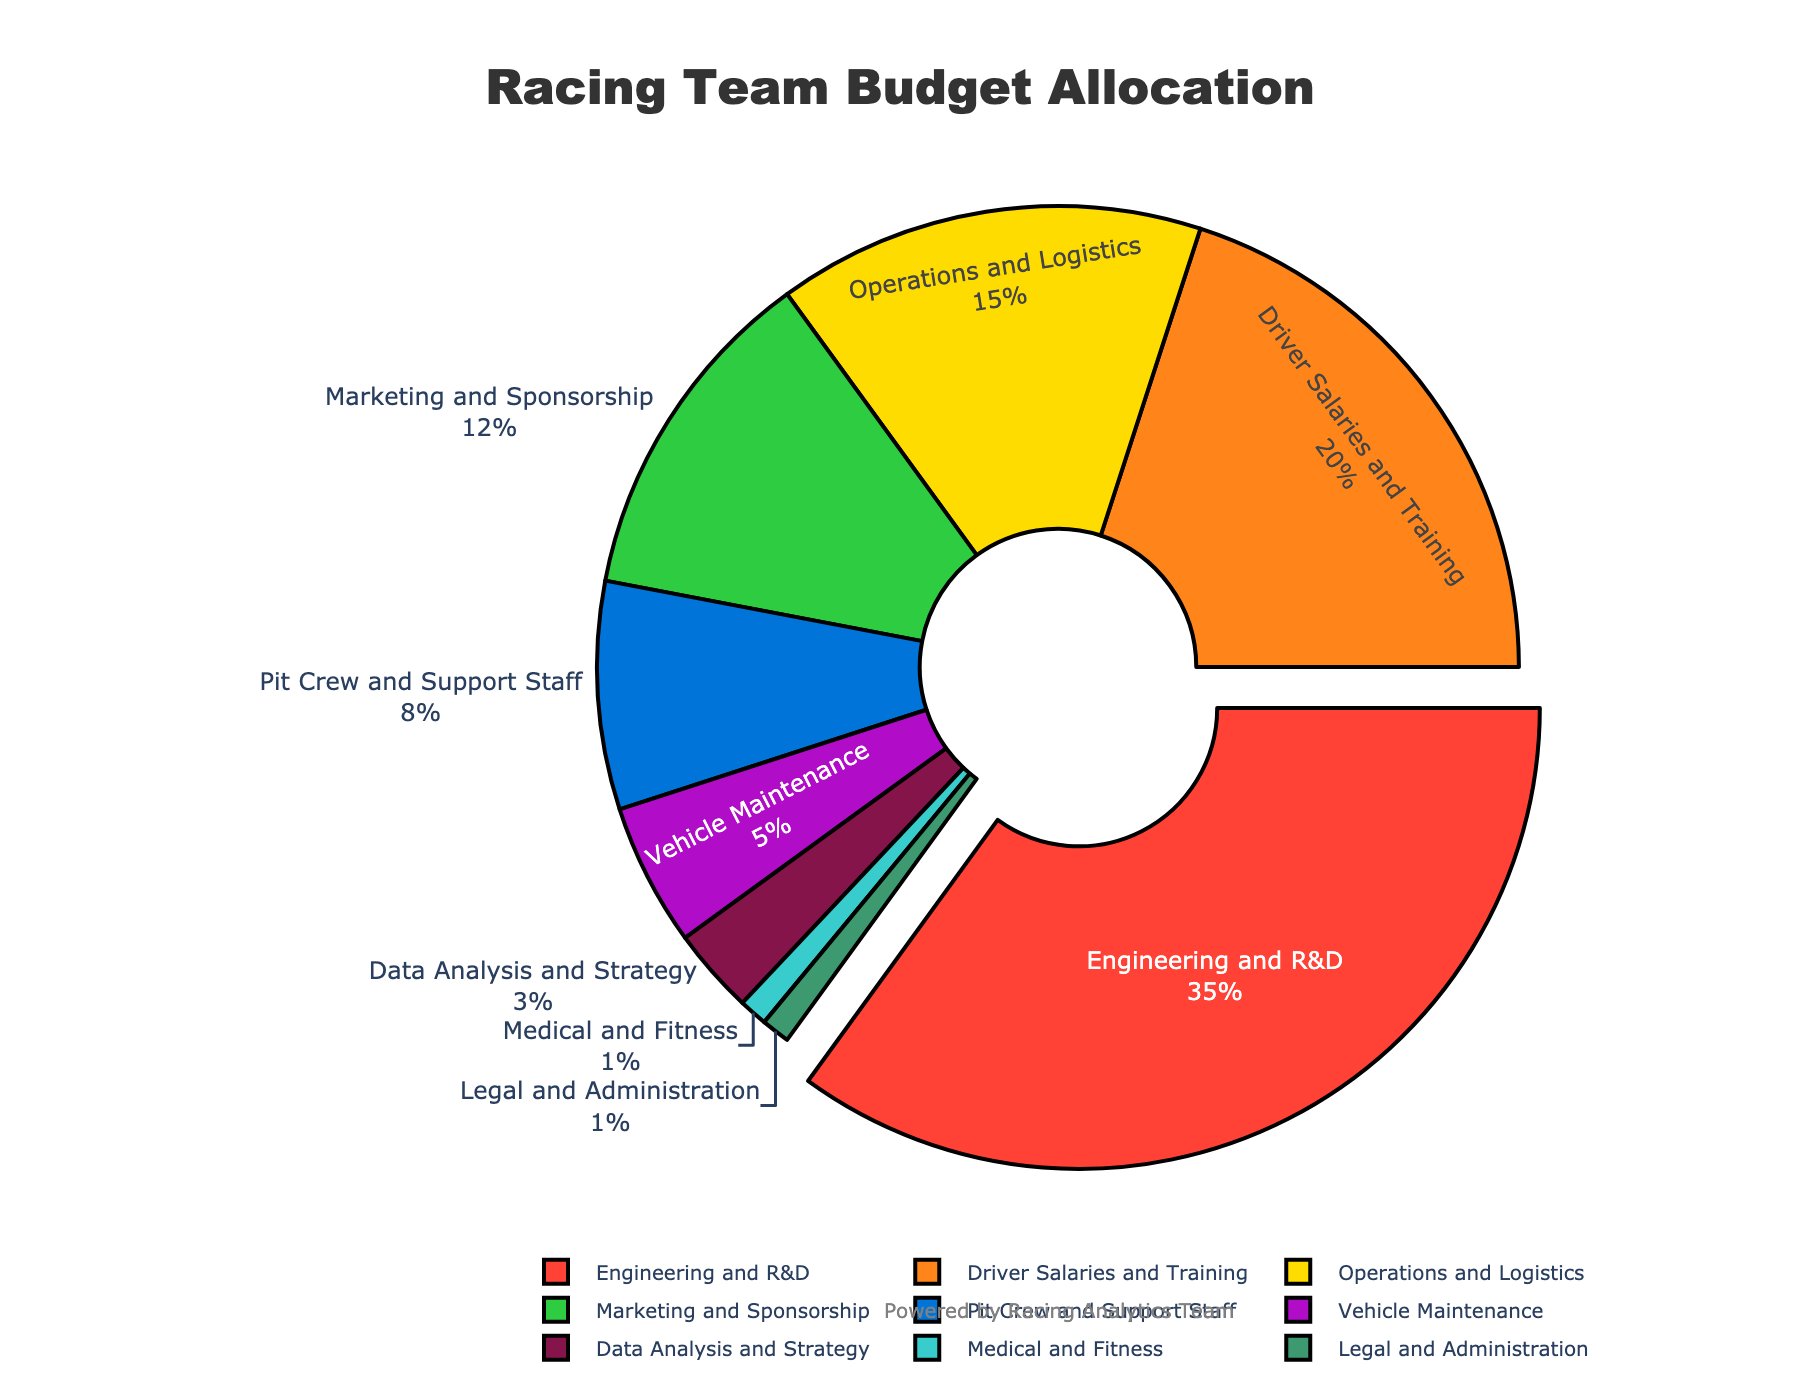What percentage of the budget is allocated to Engineering and R&D? The "Engineering and R&D" segment can be easily identified, and its percentage is marked next to it.
Answer: 35% Which two departments receive the smallest portions of the budget? By looking at the smallest segments of the pie chart and checking their labels, we see "Medical and Fitness" and "Legal and Administration"
Answer: Medical and Fitness and Legal and Administration How much more budget is allocated to Engineering and R&D compared to Marketing and Sponsorship? First, find the percentage for each department: Engineering and R&D (35%) and Marketing and Sponsorship (12%). Then subtract the two values: 35% - 12% = 23%
Answer: 23% Which department has the third highest budget allocation? By ordering the segments in descending order of their percentages, the top three are "Engineering and R&D", "Driver Salaries and Training", and "Operations and Logistics".
Answer: Operations and Logistics What is the combined budget allocation for Driver Salaries and Training and Operations and Logistics? Adding the percentages of "Driver Salaries and Training" (20%) and "Operations and Logistics" (15%) gives 20% + 15% = 35%
Answer: 35% How much more budget percentage does the Engineering and R&D department have compared to the Pit Crew and Support Staff? Subtract the budget percentage of the Pit Crew and Support Staff (8%) from Engineering and R&D (35%): 35% - 8% = 27%
Answer: 27% Are there any departments that receive an equal percentage of the budget? By examining each percentage listed, we see that both "Medical and Fitness" and "Legal and Administration" receive 1% each.
Answer: Yes Which segment of the pie chart is colored red? By identifying the colors used, the segment colored red is "Engineering and R&D".
Answer: Engineering and R&D What proportion of the budget is allocated to departments related to direct race-day activities (Driver Salaries and Training, Pit Crew and Support Staff)? Adding percentages of "Driver Salaries and Training" (20%) and "Pit Crew and Support Staff" (8%) gives 20% + 8% = 28%
Answer: 28% How does the budget for Vehicle Maintenance compare to Data Analysis and Strategy? By comparing the percentages, Vehicle Maintenance has 5%, and Data Analysis and Strategy has 3%, so Vehicle Maintenance has 2% more.
Answer: 2% more 